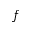<formula> <loc_0><loc_0><loc_500><loc_500>f</formula> 